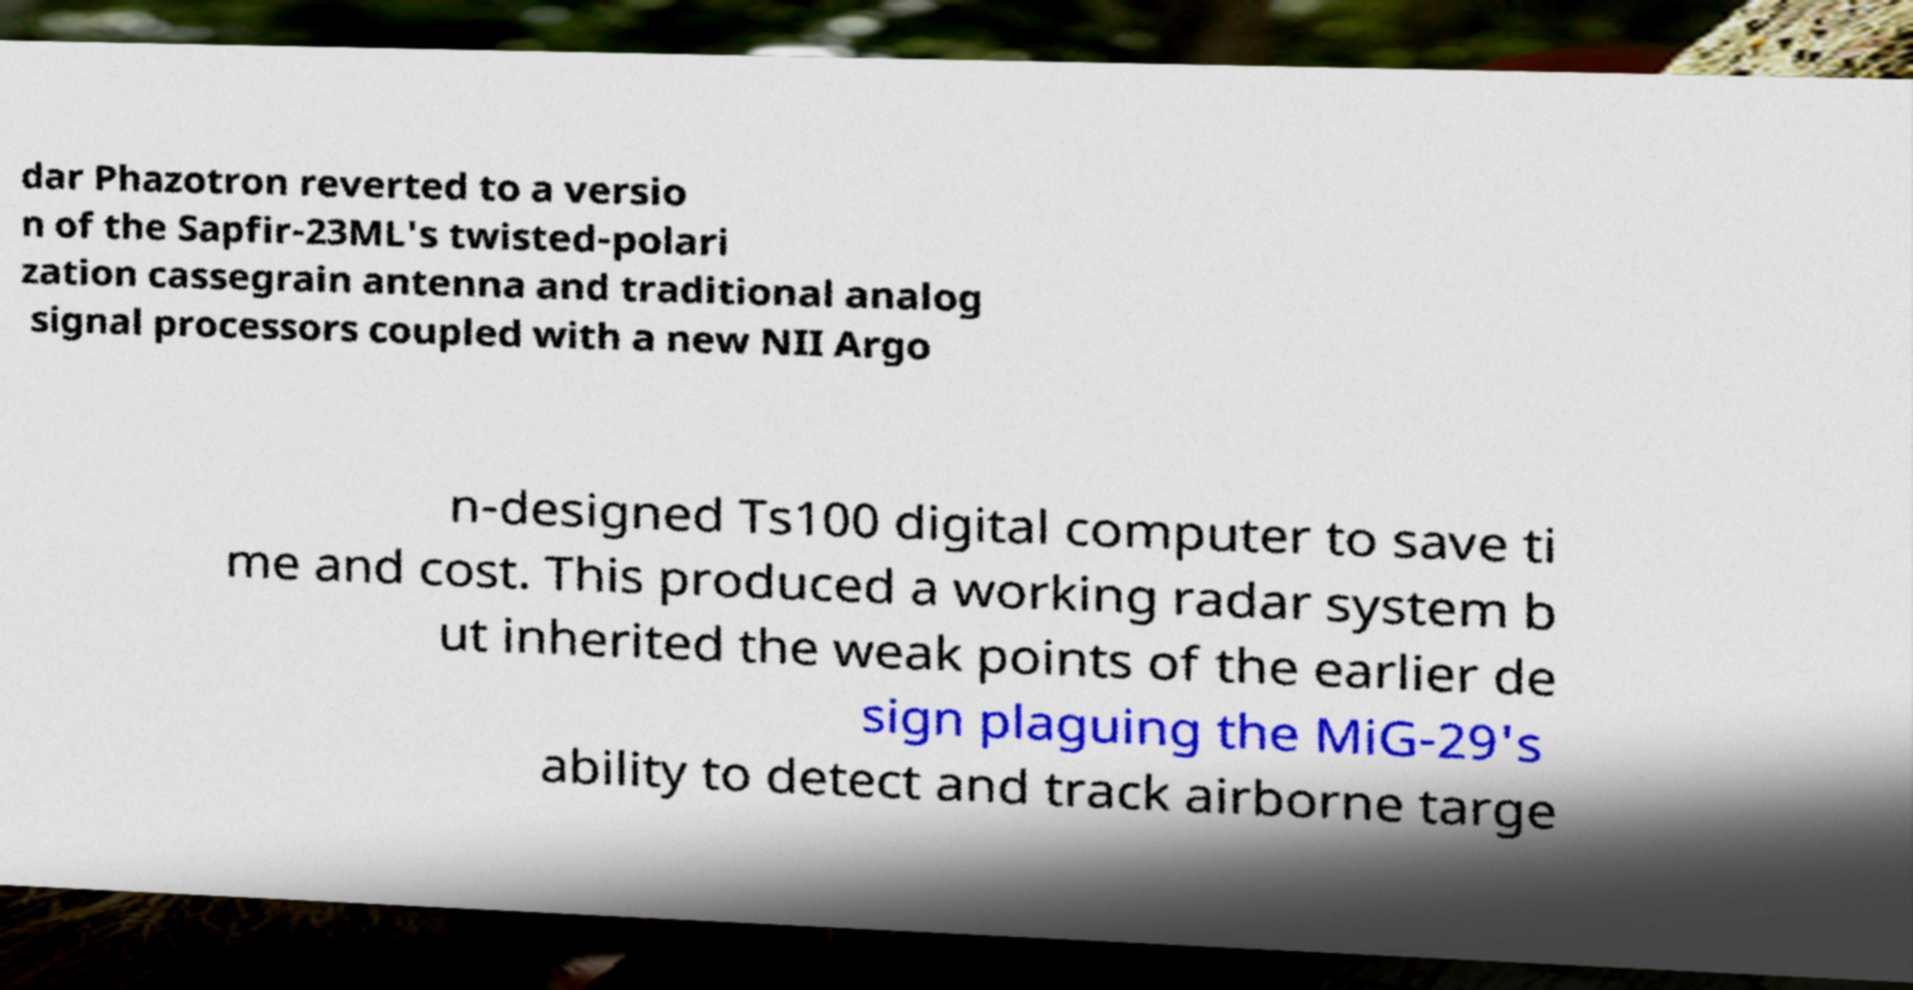Can you read and provide the text displayed in the image?This photo seems to have some interesting text. Can you extract and type it out for me? dar Phazotron reverted to a versio n of the Sapfir-23ML's twisted-polari zation cassegrain antenna and traditional analog signal processors coupled with a new NII Argo n-designed Ts100 digital computer to save ti me and cost. This produced a working radar system b ut inherited the weak points of the earlier de sign plaguing the MiG-29's ability to detect and track airborne targe 